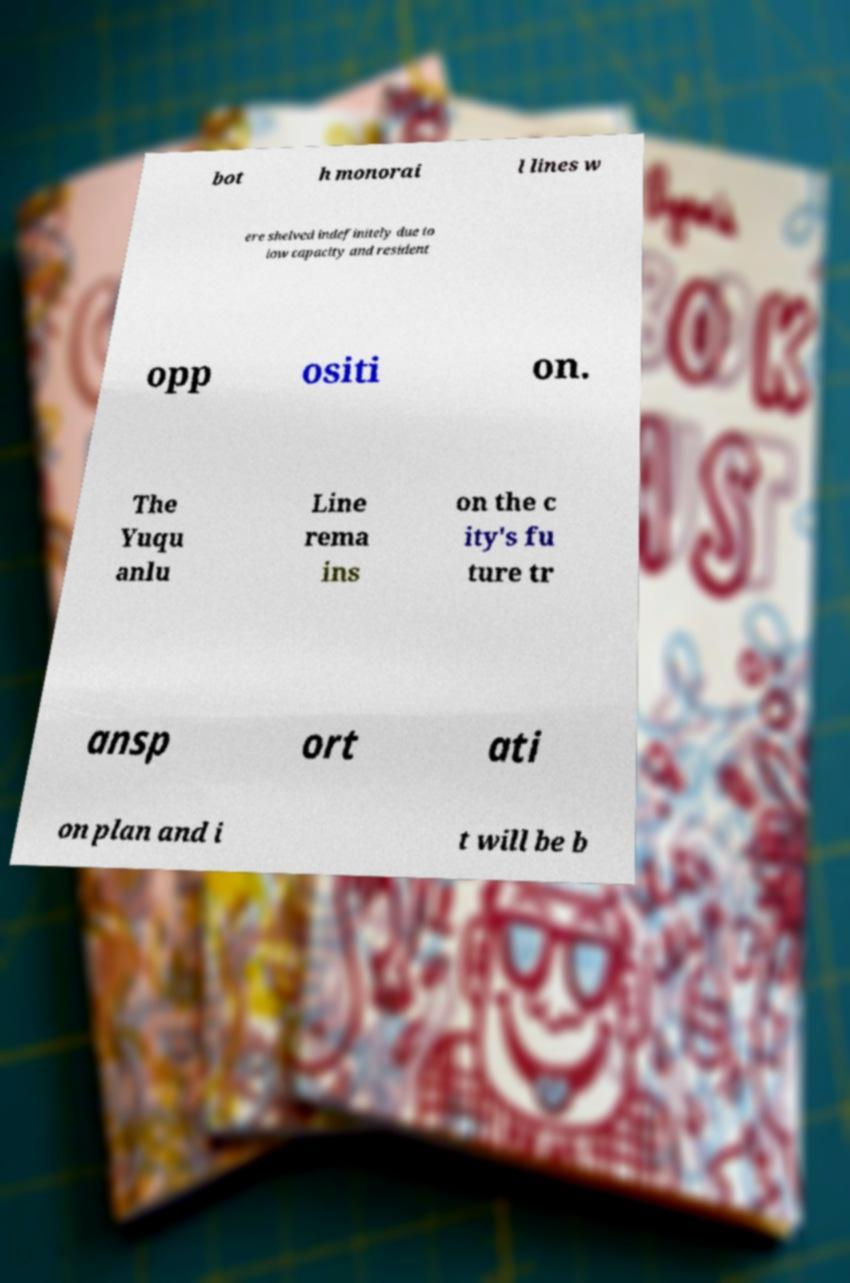For documentation purposes, I need the text within this image transcribed. Could you provide that? bot h monorai l lines w ere shelved indefinitely due to low capacity and resident opp ositi on. The Yuqu anlu Line rema ins on the c ity's fu ture tr ansp ort ati on plan and i t will be b 